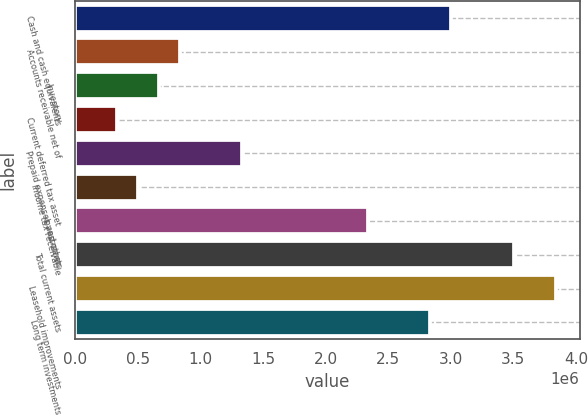<chart> <loc_0><loc_0><loc_500><loc_500><bar_chart><fcel>Cash and cash equivalents<fcel>Accounts receivable net of<fcel>Inventory<fcel>Current deferred tax asset<fcel>Prepaid expenses and other<fcel>Income tax receivable<fcel>Investments<fcel>Total current assets<fcel>Leasehold improvements<fcel>Long term investments<nl><fcel>3.00332e+06<fcel>834508<fcel>667676<fcel>334013<fcel>1.335e+06<fcel>500844<fcel>2.33599e+06<fcel>3.50382e+06<fcel>3.83748e+06<fcel>2.83649e+06<nl></chart> 